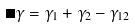Convert formula to latex. <formula><loc_0><loc_0><loc_500><loc_500>\Delta \gamma = \gamma _ { 1 } + \gamma _ { 2 } - \gamma _ { 1 2 }</formula> 